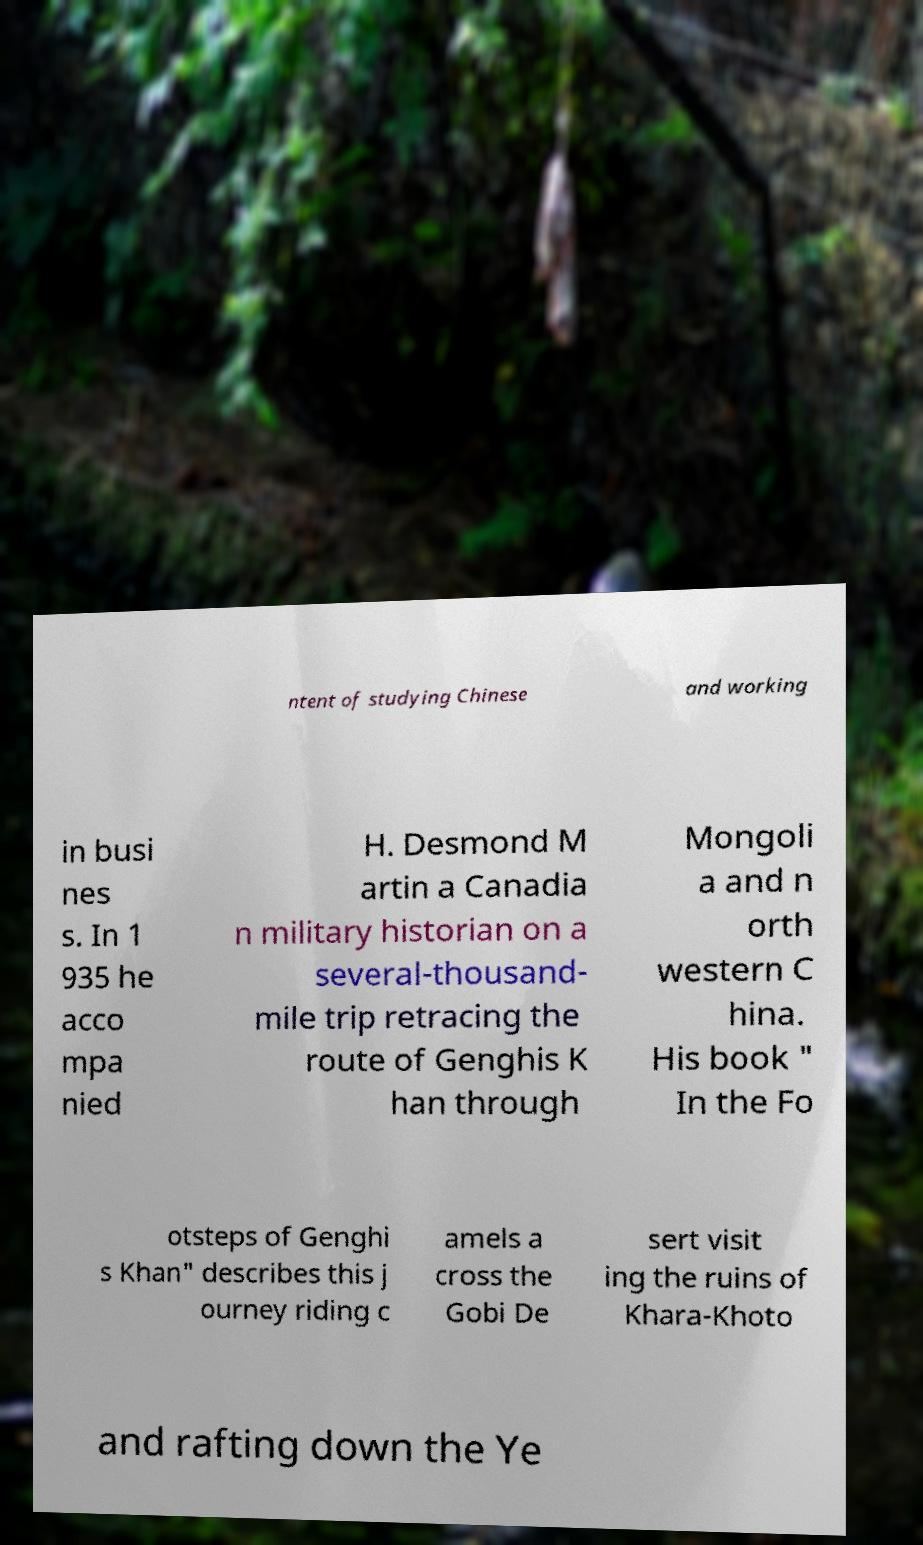Could you extract and type out the text from this image? ntent of studying Chinese and working in busi nes s. In 1 935 he acco mpa nied H. Desmond M artin a Canadia n military historian on a several-thousand- mile trip retracing the route of Genghis K han through Mongoli a and n orth western C hina. His book " In the Fo otsteps of Genghi s Khan" describes this j ourney riding c amels a cross the Gobi De sert visit ing the ruins of Khara-Khoto and rafting down the Ye 